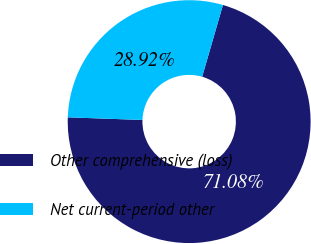<chart> <loc_0><loc_0><loc_500><loc_500><pie_chart><fcel>Other comprehensive (loss)<fcel>Net current-period other<nl><fcel>71.08%<fcel>28.92%<nl></chart> 